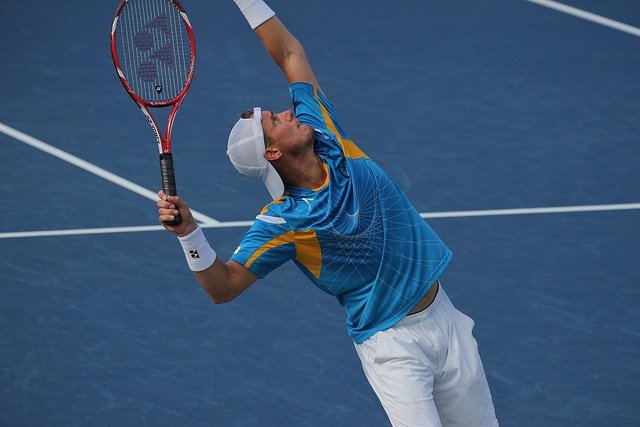Describe the objects in this image and their specific colors. I can see people in darkblue, blue, darkgray, and navy tones and tennis racket in darkblue, blue, gray, black, and navy tones in this image. 